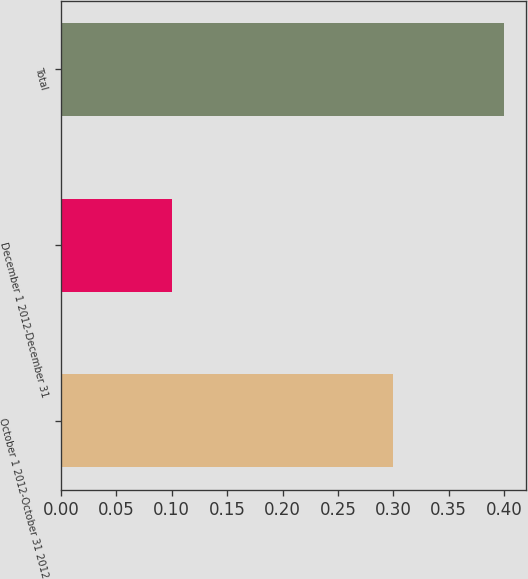Convert chart to OTSL. <chart><loc_0><loc_0><loc_500><loc_500><bar_chart><fcel>October 1 2012-October 31 2012<fcel>December 1 2012-December 31<fcel>Total<nl><fcel>0.3<fcel>0.1<fcel>0.4<nl></chart> 